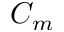Convert formula to latex. <formula><loc_0><loc_0><loc_500><loc_500>C _ { m }</formula> 